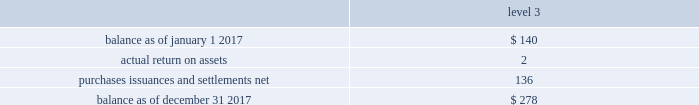The tables present a reconciliation of the beginning and ending balances of the fair value measurements using significant unobservable inputs ( level 3 ) for 2017 and 2016 , respectively: .
Purchases , issuances and settlements , net .
( 4 ) balance as of december 31 , 2016 .
$ 140 the company 2019s postretirement benefit plans have different levels of funded status and the assets are held under various trusts .
The investments and risk mitigation strategies for the plans are tailored specifically for each trust .
In setting new strategic asset mixes , consideration is given to the likelihood that the selected asset allocation will effectively fund the projected plan liabilities and meet the risk tolerance criteria of the company .
The company periodically updates the long-term , strategic asset allocations for these plans through asset liability studies and uses various analytics to determine the optimal asset allocation .
Considerations include plan liability characteristics , liquidity needs , funding requirements , expected rates of return and the distribution of returns .
Strategies to address the goal of ensuring sufficient assets to pay benefits include target allocations to a broad array of asset classes and , within asset classes , strategies are employed to provide adequate returns , diversification and liquidity .
In 2012 , the company implemented a de-risking strategy for the american water pension plan after conducting an asset-liability study to reduce the volatility of the funded status of the plan .
As part of the de-risking strategy , the company revised the asset allocations to increase the matching characteristics of fixed-income assets relative to liabilities .
The fixed income portion of the portfolio was designed to match the bond-like and long-dated nature of the postretirement liabilities .
In 2017 , the company further increased its exposure to liability-driven investing and increased its fixed-income allocation to 50% ( 50 % ) , up from 40% ( 40 % ) , in an effort to further decrease the funded status volatility of the plan and hedge the portfolio from movements in interest rates .
In 2012 , the company also implemented a de-risking strategy for the medical bargaining trust within the plan to minimize volatility .
In 2017 , the company conducted a new asset-liability study that indicated medical trend inflation that outpaced the consumer price index by more than 2% ( 2 % ) for the last 20 years .
Given continuously rising medical costs , the company decided to increase the equity exposure of the portfolio to 30% ( 30 % ) , up from 20% ( 20 % ) , while reducing the fixed-income portion of the portfolio from 80% ( 80 % ) to 70% ( 70 % ) .
The company also conducted an asset-liability study for the post-retirement non-bargaining medical plan .
Its allocation was adjusted to make it more conservative , reducing the equity allocation from 70% ( 70 % ) to 60% ( 60 % ) and increasing the fixed- income allocation from 30% ( 30 % ) to 40% ( 40 % ) .
The post-retirement medical non-bargaining plan 2019s equity allocation was reduced due to the cap on benefits for some non-union participants and resultant reduction in the plan 2019s liabilities .
These changes will take place in 2018 .
The company engages third party investment managers for all invested assets .
Managers are not permitted to invest outside of the asset class ( e.g .
Fixed income , equity , alternatives ) or strategy for which they have been appointed .
Investment management agreements and recurring performance and attribution analysis are used as tools to ensure investment managers invest solely within the investment strategy they have been provided .
Futures and options may be used to adjust portfolio duration to align with a plan 2019s targeted investment policy. .
In 2017 what was the percent of the return on assets to the balance at the end of december? 
Computations: (2 / 278)
Answer: 0.00719. The tables present a reconciliation of the beginning and ending balances of the fair value measurements using significant unobservable inputs ( level 3 ) for 2017 and 2016 , respectively: .
Purchases , issuances and settlements , net .
( 4 ) balance as of december 31 , 2016 .
$ 140 the company 2019s postretirement benefit plans have different levels of funded status and the assets are held under various trusts .
The investments and risk mitigation strategies for the plans are tailored specifically for each trust .
In setting new strategic asset mixes , consideration is given to the likelihood that the selected asset allocation will effectively fund the projected plan liabilities and meet the risk tolerance criteria of the company .
The company periodically updates the long-term , strategic asset allocations for these plans through asset liability studies and uses various analytics to determine the optimal asset allocation .
Considerations include plan liability characteristics , liquidity needs , funding requirements , expected rates of return and the distribution of returns .
Strategies to address the goal of ensuring sufficient assets to pay benefits include target allocations to a broad array of asset classes and , within asset classes , strategies are employed to provide adequate returns , diversification and liquidity .
In 2012 , the company implemented a de-risking strategy for the american water pension plan after conducting an asset-liability study to reduce the volatility of the funded status of the plan .
As part of the de-risking strategy , the company revised the asset allocations to increase the matching characteristics of fixed-income assets relative to liabilities .
The fixed income portion of the portfolio was designed to match the bond-like and long-dated nature of the postretirement liabilities .
In 2017 , the company further increased its exposure to liability-driven investing and increased its fixed-income allocation to 50% ( 50 % ) , up from 40% ( 40 % ) , in an effort to further decrease the funded status volatility of the plan and hedge the portfolio from movements in interest rates .
In 2012 , the company also implemented a de-risking strategy for the medical bargaining trust within the plan to minimize volatility .
In 2017 , the company conducted a new asset-liability study that indicated medical trend inflation that outpaced the consumer price index by more than 2% ( 2 % ) for the last 20 years .
Given continuously rising medical costs , the company decided to increase the equity exposure of the portfolio to 30% ( 30 % ) , up from 20% ( 20 % ) , while reducing the fixed-income portion of the portfolio from 80% ( 80 % ) to 70% ( 70 % ) .
The company also conducted an asset-liability study for the post-retirement non-bargaining medical plan .
Its allocation was adjusted to make it more conservative , reducing the equity allocation from 70% ( 70 % ) to 60% ( 60 % ) and increasing the fixed- income allocation from 30% ( 30 % ) to 40% ( 40 % ) .
The post-retirement medical non-bargaining plan 2019s equity allocation was reduced due to the cap on benefits for some non-union participants and resultant reduction in the plan 2019s liabilities .
These changes will take place in 2018 .
The company engages third party investment managers for all invested assets .
Managers are not permitted to invest outside of the asset class ( e.g .
Fixed income , equity , alternatives ) or strategy for which they have been appointed .
Investment management agreements and recurring performance and attribution analysis are used as tools to ensure investment managers invest solely within the investment strategy they have been provided .
Futures and options may be used to adjust portfolio duration to align with a plan 2019s targeted investment policy. .
By how much did the balance increase from the beginning of 2017 to the end? 
Computations: ((278 - 140) / 140)
Answer: 0.98571. The tables present a reconciliation of the beginning and ending balances of the fair value measurements using significant unobservable inputs ( level 3 ) for 2017 and 2016 , respectively: .
Purchases , issuances and settlements , net .
( 4 ) balance as of december 31 , 2016 .
$ 140 the company 2019s postretirement benefit plans have different levels of funded status and the assets are held under various trusts .
The investments and risk mitigation strategies for the plans are tailored specifically for each trust .
In setting new strategic asset mixes , consideration is given to the likelihood that the selected asset allocation will effectively fund the projected plan liabilities and meet the risk tolerance criteria of the company .
The company periodically updates the long-term , strategic asset allocations for these plans through asset liability studies and uses various analytics to determine the optimal asset allocation .
Considerations include plan liability characteristics , liquidity needs , funding requirements , expected rates of return and the distribution of returns .
Strategies to address the goal of ensuring sufficient assets to pay benefits include target allocations to a broad array of asset classes and , within asset classes , strategies are employed to provide adequate returns , diversification and liquidity .
In 2012 , the company implemented a de-risking strategy for the american water pension plan after conducting an asset-liability study to reduce the volatility of the funded status of the plan .
As part of the de-risking strategy , the company revised the asset allocations to increase the matching characteristics of fixed-income assets relative to liabilities .
The fixed income portion of the portfolio was designed to match the bond-like and long-dated nature of the postretirement liabilities .
In 2017 , the company further increased its exposure to liability-driven investing and increased its fixed-income allocation to 50% ( 50 % ) , up from 40% ( 40 % ) , in an effort to further decrease the funded status volatility of the plan and hedge the portfolio from movements in interest rates .
In 2012 , the company also implemented a de-risking strategy for the medical bargaining trust within the plan to minimize volatility .
In 2017 , the company conducted a new asset-liability study that indicated medical trend inflation that outpaced the consumer price index by more than 2% ( 2 % ) for the last 20 years .
Given continuously rising medical costs , the company decided to increase the equity exposure of the portfolio to 30% ( 30 % ) , up from 20% ( 20 % ) , while reducing the fixed-income portion of the portfolio from 80% ( 80 % ) to 70% ( 70 % ) .
The company also conducted an asset-liability study for the post-retirement non-bargaining medical plan .
Its allocation was adjusted to make it more conservative , reducing the equity allocation from 70% ( 70 % ) to 60% ( 60 % ) and increasing the fixed- income allocation from 30% ( 30 % ) to 40% ( 40 % ) .
The post-retirement medical non-bargaining plan 2019s equity allocation was reduced due to the cap on benefits for some non-union participants and resultant reduction in the plan 2019s liabilities .
These changes will take place in 2018 .
The company engages third party investment managers for all invested assets .
Managers are not permitted to invest outside of the asset class ( e.g .
Fixed income , equity , alternatives ) or strategy for which they have been appointed .
Investment management agreements and recurring performance and attribution analysis are used as tools to ensure investment managers invest solely within the investment strategy they have been provided .
Futures and options may be used to adjust portfolio duration to align with a plan 2019s targeted investment policy. .
What was the growth in the account balance in 2017? 
Computations: ((278 - 140) / 140)
Answer: 0.98571. 